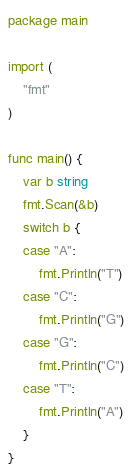Convert code to text. <code><loc_0><loc_0><loc_500><loc_500><_Go_>package main

import (
	"fmt"
)

func main() {
	var b string
	fmt.Scan(&b)
	switch b {
	case "A":
		fmt.Println("T")
	case "C":
		fmt.Println("G")
	case "G":
		fmt.Println("C")
	case "T":
		fmt.Println("A")
	}
}
</code> 